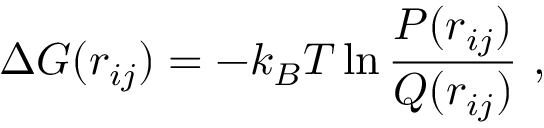Convert formula to latex. <formula><loc_0><loc_0><loc_500><loc_500>\Delta G ( r _ { i j } ) = - k _ { B } T \ln \frac { P ( r _ { i j } ) } { Q ( r _ { i j } ) } ,</formula> 